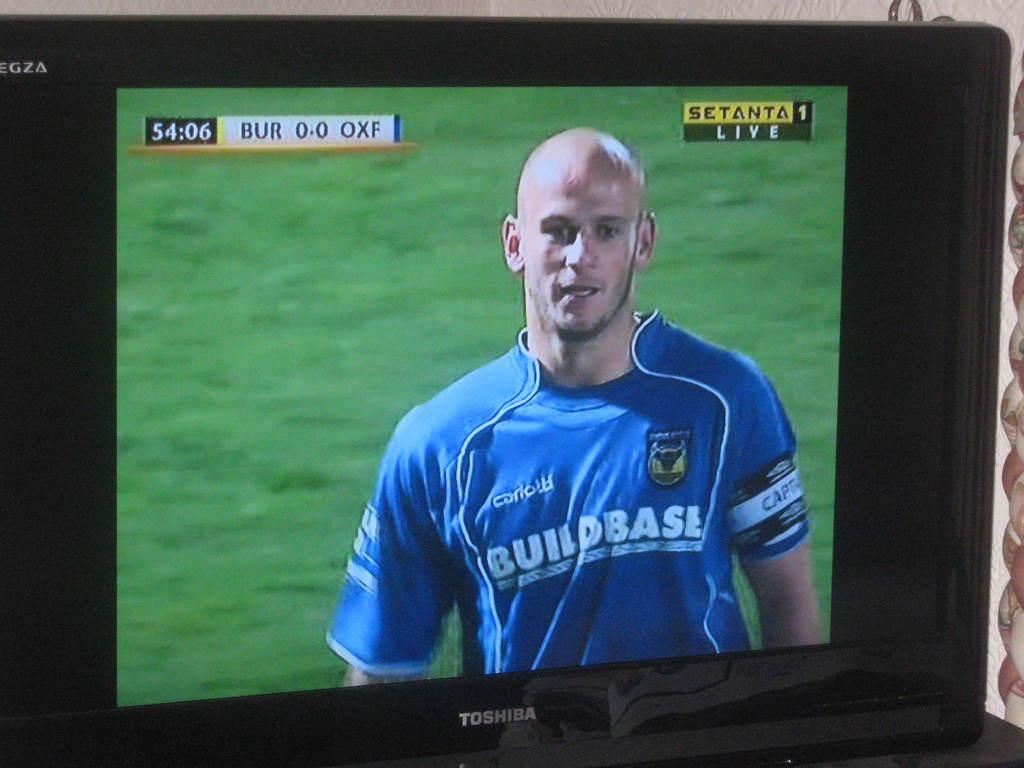<image>
Write a terse but informative summary of the picture. A soccer game host on the Setanta 1 Live channel. 